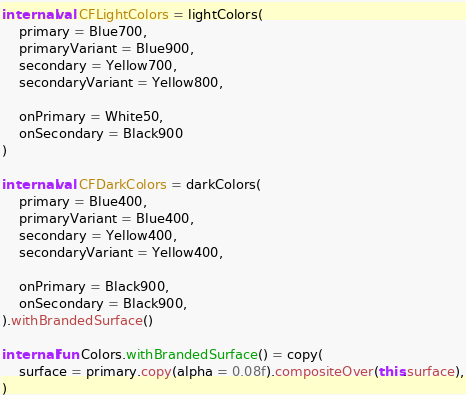<code> <loc_0><loc_0><loc_500><loc_500><_Kotlin_>
internal val CFLightColors = lightColors(
    primary = Blue700,
    primaryVariant = Blue900,
    secondary = Yellow700,
    secondaryVariant = Yellow800,

    onPrimary = White50,
    onSecondary = Black900
)

internal val CFDarkColors = darkColors(
    primary = Blue400,
    primaryVariant = Blue400,
    secondary = Yellow400,
    secondaryVariant = Yellow400,

    onPrimary = Black900,
    onSecondary = Black900,
).withBrandedSurface()

internal fun Colors.withBrandedSurface() = copy(
    surface = primary.copy(alpha = 0.08f).compositeOver(this.surface),
)</code> 